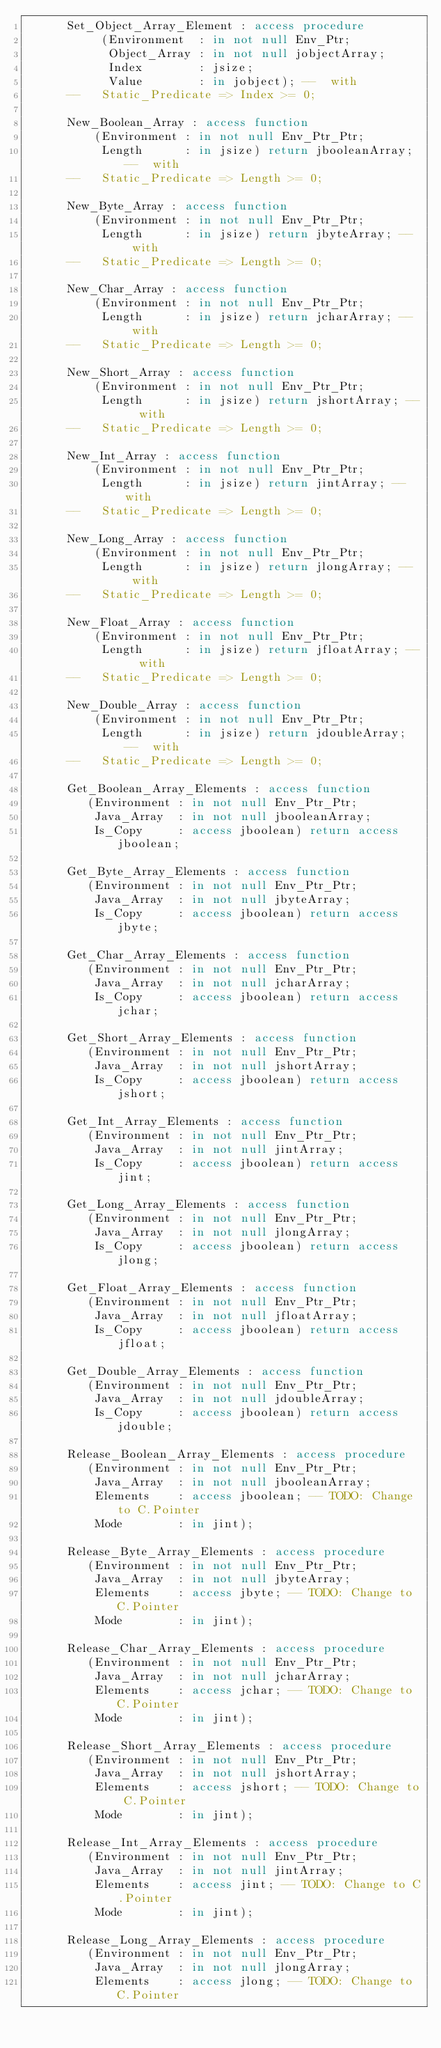Convert code to text. <code><loc_0><loc_0><loc_500><loc_500><_Ada_>      Set_Object_Array_Element : access procedure
           (Environment  : in not null Env_Ptr;
            Object_Array : in not null jobjectArray;
            Index        : jsize;
            Value        : in jobject); --  with
      --   Static_Predicate => Index >= 0;

      New_Boolean_Array : access function
          (Environment : in not null Env_Ptr_Ptr;
           Length      : in jsize) return jbooleanArray; --  with
      --   Static_Predicate => Length >= 0;

      New_Byte_Array : access function
          (Environment : in not null Env_Ptr_Ptr;
           Length      : in jsize) return jbyteArray; --  with
      --   Static_Predicate => Length >= 0;

      New_Char_Array : access function
          (Environment : in not null Env_Ptr_Ptr;
           Length      : in jsize) return jcharArray; --  with
      --   Static_Predicate => Length >= 0;

      New_Short_Array : access function
          (Environment : in not null Env_Ptr_Ptr;
           Length      : in jsize) return jshortArray; --  with
      --   Static_Predicate => Length >= 0;

      New_Int_Array : access function
          (Environment : in not null Env_Ptr_Ptr;
           Length      : in jsize) return jintArray; --  with
      --   Static_Predicate => Length >= 0;

      New_Long_Array : access function
          (Environment : in not null Env_Ptr_Ptr;
           Length      : in jsize) return jlongArray; --  with
      --   Static_Predicate => Length >= 0;

      New_Float_Array : access function
          (Environment : in not null Env_Ptr_Ptr;
           Length      : in jsize) return jfloatArray; --  with
      --   Static_Predicate => Length >= 0;

      New_Double_Array : access function
          (Environment : in not null Env_Ptr_Ptr;
           Length      : in jsize) return jdoubleArray; --  with
      --   Static_Predicate => Length >= 0;

      Get_Boolean_Array_Elements : access function
         (Environment : in not null Env_Ptr_Ptr;
          Java_Array  : in not null jbooleanArray;
          Is_Copy     : access jboolean) return access jboolean;

      Get_Byte_Array_Elements : access function
         (Environment : in not null Env_Ptr_Ptr;
          Java_Array  : in not null jbyteArray;
          Is_Copy     : access jboolean) return access jbyte;

      Get_Char_Array_Elements : access function
         (Environment : in not null Env_Ptr_Ptr;
          Java_Array  : in not null jcharArray;
          Is_Copy     : access jboolean) return access jchar;

      Get_Short_Array_Elements : access function
         (Environment : in not null Env_Ptr_Ptr;
          Java_Array  : in not null jshortArray;
          Is_Copy     : access jboolean) return access jshort;

      Get_Int_Array_Elements : access function
         (Environment : in not null Env_Ptr_Ptr;
          Java_Array  : in not null jintArray;
          Is_Copy     : access jboolean) return access jint;

      Get_Long_Array_Elements : access function
         (Environment : in not null Env_Ptr_Ptr;
          Java_Array  : in not null jlongArray;
          Is_Copy     : access jboolean) return access jlong;

      Get_Float_Array_Elements : access function
         (Environment : in not null Env_Ptr_Ptr;
          Java_Array  : in not null jfloatArray;
          Is_Copy     : access jboolean) return access jfloat;

      Get_Double_Array_Elements : access function
         (Environment : in not null Env_Ptr_Ptr;
          Java_Array  : in not null jdoubleArray;
          Is_Copy     : access jboolean) return access jdouble;

      Release_Boolean_Array_Elements : access procedure
         (Environment : in not null Env_Ptr_Ptr;
          Java_Array  : in not null jbooleanArray;
          Elements    : access jboolean; -- TODO: Change to C.Pointer
          Mode        : in jint);

      Release_Byte_Array_Elements : access procedure
         (Environment : in not null Env_Ptr_Ptr;
          Java_Array  : in not null jbyteArray;
          Elements    : access jbyte; -- TODO: Change to C.Pointer
          Mode        : in jint);

      Release_Char_Array_Elements : access procedure
         (Environment : in not null Env_Ptr_Ptr;
          Java_Array  : in not null jcharArray;
          Elements    : access jchar; -- TODO: Change to C.Pointer
          Mode        : in jint);

      Release_Short_Array_Elements : access procedure
         (Environment : in not null Env_Ptr_Ptr;
          Java_Array  : in not null jshortArray;
          Elements    : access jshort; -- TODO: Change to C.Pointer
          Mode        : in jint);

      Release_Int_Array_Elements : access procedure
         (Environment : in not null Env_Ptr_Ptr;
          Java_Array  : in not null jintArray;
          Elements    : access jint; -- TODO: Change to C.Pointer
          Mode        : in jint);

      Release_Long_Array_Elements : access procedure
         (Environment : in not null Env_Ptr_Ptr;
          Java_Array  : in not null jlongArray;
          Elements    : access jlong; -- TODO: Change to C.Pointer</code> 